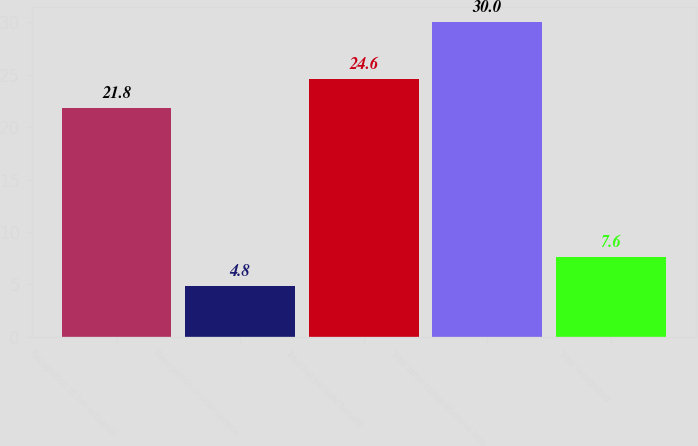Convert chart to OTSL. <chart><loc_0><loc_0><loc_500><loc_500><bar_chart><fcel>Recognition of net actuarial<fcel>Recognition of prior service<fcel>Total net periodic benefit<fcel>Total other comprehensive loss<fcel>Total recognized<nl><fcel>21.8<fcel>4.8<fcel>24.6<fcel>30<fcel>7.6<nl></chart> 